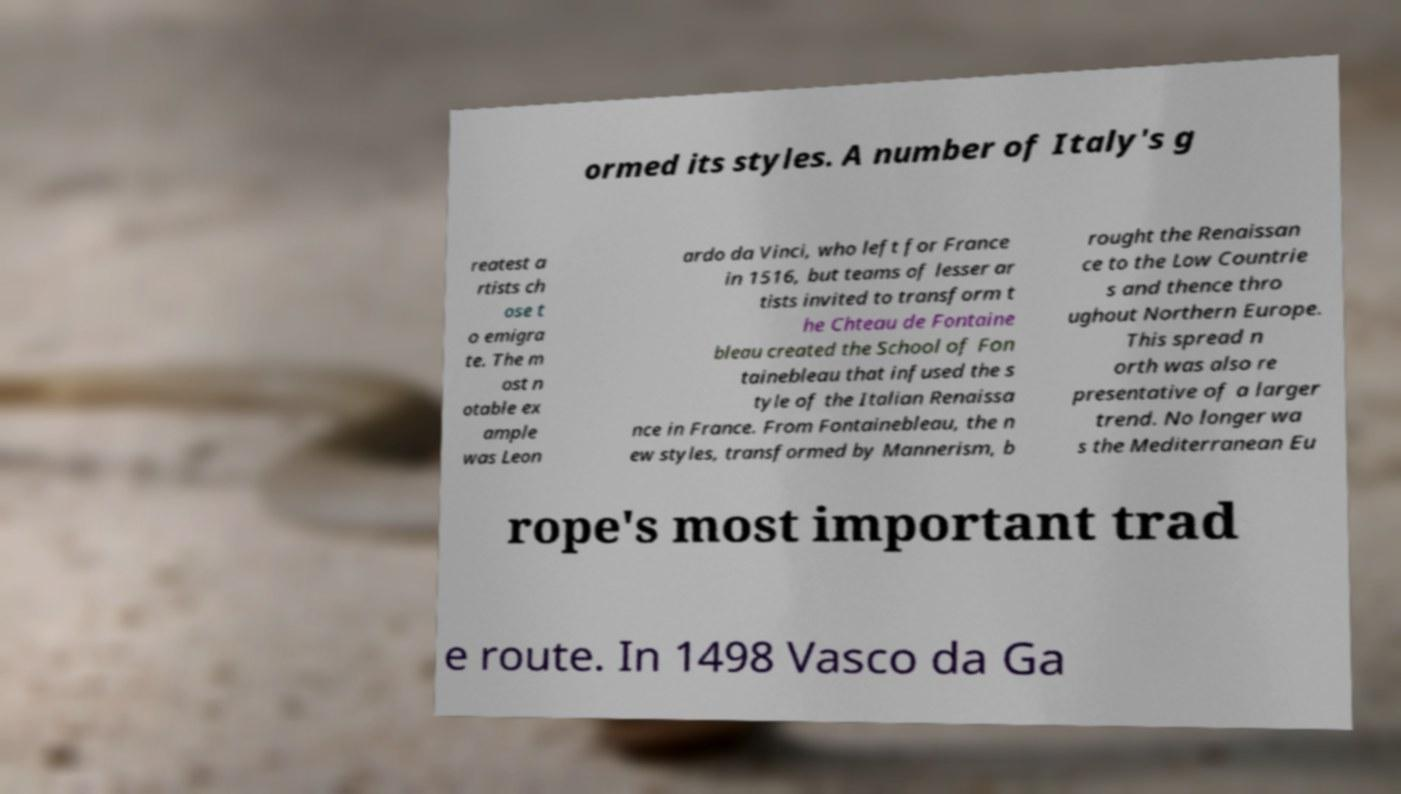Can you accurately transcribe the text from the provided image for me? ormed its styles. A number of Italy's g reatest a rtists ch ose t o emigra te. The m ost n otable ex ample was Leon ardo da Vinci, who left for France in 1516, but teams of lesser ar tists invited to transform t he Chteau de Fontaine bleau created the School of Fon tainebleau that infused the s tyle of the Italian Renaissa nce in France. From Fontainebleau, the n ew styles, transformed by Mannerism, b rought the Renaissan ce to the Low Countrie s and thence thro ughout Northern Europe. This spread n orth was also re presentative of a larger trend. No longer wa s the Mediterranean Eu rope's most important trad e route. In 1498 Vasco da Ga 